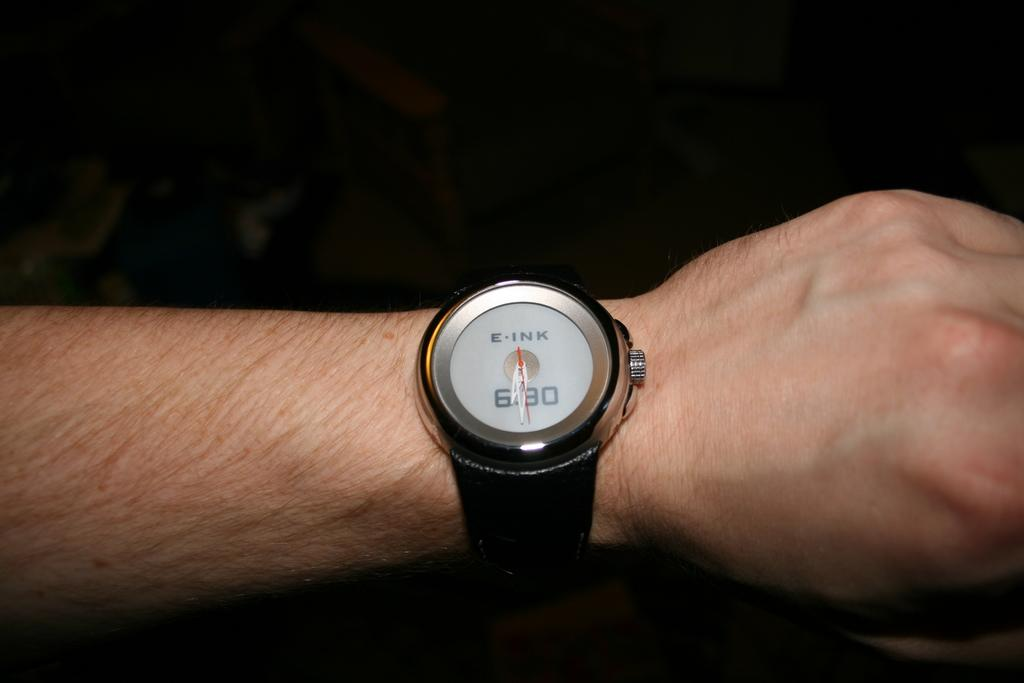What part of a person's body is visible in the image? There is a person's hand in the image. What accessory is the person's hand wearing? The person's hand is wearing a wrist watch. What type of locket can be seen hanging from the person's hand in the image? There is no locket present in the image; only a wrist watch is visible on the person's hand. 